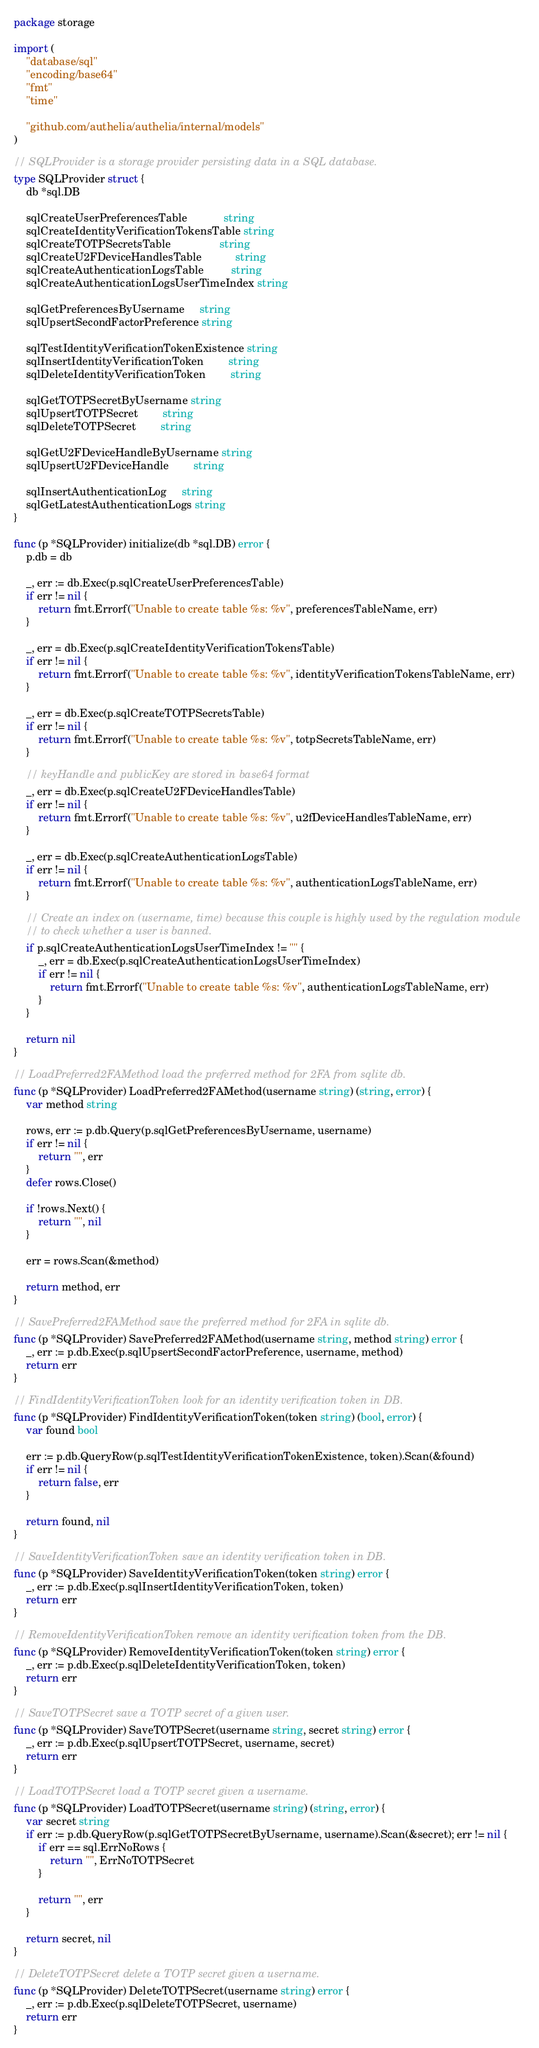<code> <loc_0><loc_0><loc_500><loc_500><_Go_>package storage

import (
	"database/sql"
	"encoding/base64"
	"fmt"
	"time"

	"github.com/authelia/authelia/internal/models"
)

// SQLProvider is a storage provider persisting data in a SQL database.
type SQLProvider struct {
	db *sql.DB

	sqlCreateUserPreferencesTable            string
	sqlCreateIdentityVerificationTokensTable string
	sqlCreateTOTPSecretsTable                string
	sqlCreateU2FDeviceHandlesTable           string
	sqlCreateAuthenticationLogsTable         string
	sqlCreateAuthenticationLogsUserTimeIndex string

	sqlGetPreferencesByUsername     string
	sqlUpsertSecondFactorPreference string

	sqlTestIdentityVerificationTokenExistence string
	sqlInsertIdentityVerificationToken        string
	sqlDeleteIdentityVerificationToken        string

	sqlGetTOTPSecretByUsername string
	sqlUpsertTOTPSecret        string
	sqlDeleteTOTPSecret        string

	sqlGetU2FDeviceHandleByUsername string
	sqlUpsertU2FDeviceHandle        string

	sqlInsertAuthenticationLog     string
	sqlGetLatestAuthenticationLogs string
}

func (p *SQLProvider) initialize(db *sql.DB) error {
	p.db = db

	_, err := db.Exec(p.sqlCreateUserPreferencesTable)
	if err != nil {
		return fmt.Errorf("Unable to create table %s: %v", preferencesTableName, err)
	}

	_, err = db.Exec(p.sqlCreateIdentityVerificationTokensTable)
	if err != nil {
		return fmt.Errorf("Unable to create table %s: %v", identityVerificationTokensTableName, err)
	}

	_, err = db.Exec(p.sqlCreateTOTPSecretsTable)
	if err != nil {
		return fmt.Errorf("Unable to create table %s: %v", totpSecretsTableName, err)
	}

	// keyHandle and publicKey are stored in base64 format
	_, err = db.Exec(p.sqlCreateU2FDeviceHandlesTable)
	if err != nil {
		return fmt.Errorf("Unable to create table %s: %v", u2fDeviceHandlesTableName, err)
	}

	_, err = db.Exec(p.sqlCreateAuthenticationLogsTable)
	if err != nil {
		return fmt.Errorf("Unable to create table %s: %v", authenticationLogsTableName, err)
	}

	// Create an index on (username, time) because this couple is highly used by the regulation module
	// to check whether a user is banned.
	if p.sqlCreateAuthenticationLogsUserTimeIndex != "" {
		_, err = db.Exec(p.sqlCreateAuthenticationLogsUserTimeIndex)
		if err != nil {
			return fmt.Errorf("Unable to create table %s: %v", authenticationLogsTableName, err)
		}
	}

	return nil
}

// LoadPreferred2FAMethod load the preferred method for 2FA from sqlite db.
func (p *SQLProvider) LoadPreferred2FAMethod(username string) (string, error) {
	var method string

	rows, err := p.db.Query(p.sqlGetPreferencesByUsername, username)
	if err != nil {
		return "", err
	}
	defer rows.Close()

	if !rows.Next() {
		return "", nil
	}

	err = rows.Scan(&method)

	return method, err
}

// SavePreferred2FAMethod save the preferred method for 2FA in sqlite db.
func (p *SQLProvider) SavePreferred2FAMethod(username string, method string) error {
	_, err := p.db.Exec(p.sqlUpsertSecondFactorPreference, username, method)
	return err
}

// FindIdentityVerificationToken look for an identity verification token in DB.
func (p *SQLProvider) FindIdentityVerificationToken(token string) (bool, error) {
	var found bool

	err := p.db.QueryRow(p.sqlTestIdentityVerificationTokenExistence, token).Scan(&found)
	if err != nil {
		return false, err
	}

	return found, nil
}

// SaveIdentityVerificationToken save an identity verification token in DB.
func (p *SQLProvider) SaveIdentityVerificationToken(token string) error {
	_, err := p.db.Exec(p.sqlInsertIdentityVerificationToken, token)
	return err
}

// RemoveIdentityVerificationToken remove an identity verification token from the DB.
func (p *SQLProvider) RemoveIdentityVerificationToken(token string) error {
	_, err := p.db.Exec(p.sqlDeleteIdentityVerificationToken, token)
	return err
}

// SaveTOTPSecret save a TOTP secret of a given user.
func (p *SQLProvider) SaveTOTPSecret(username string, secret string) error {
	_, err := p.db.Exec(p.sqlUpsertTOTPSecret, username, secret)
	return err
}

// LoadTOTPSecret load a TOTP secret given a username.
func (p *SQLProvider) LoadTOTPSecret(username string) (string, error) {
	var secret string
	if err := p.db.QueryRow(p.sqlGetTOTPSecretByUsername, username).Scan(&secret); err != nil {
		if err == sql.ErrNoRows {
			return "", ErrNoTOTPSecret
		}

		return "", err
	}

	return secret, nil
}

// DeleteTOTPSecret delete a TOTP secret given a username.
func (p *SQLProvider) DeleteTOTPSecret(username string) error {
	_, err := p.db.Exec(p.sqlDeleteTOTPSecret, username)
	return err
}
</code> 